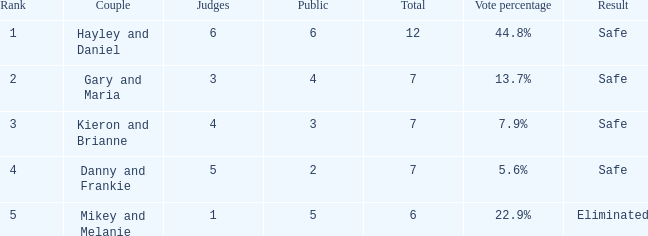Give me the full table as a dictionary. {'header': ['Rank', 'Couple', 'Judges', 'Public', 'Total', 'Vote percentage', 'Result'], 'rows': [['1', 'Hayley and Daniel', '6', '6', '12', '44.8%', 'Safe'], ['2', 'Gary and Maria', '3', '4', '7', '13.7%', 'Safe'], ['3', 'Kieron and Brianne', '4', '3', '7', '7.9%', 'Safe'], ['4', 'Danny and Frankie', '5', '2', '7', '5.6%', 'Safe'], ['5', 'Mikey and Melanie', '1', '5', '6', '22.9%', 'Eliminated']]} How many people from the public are there for the couple that was eliminated? 5.0. 